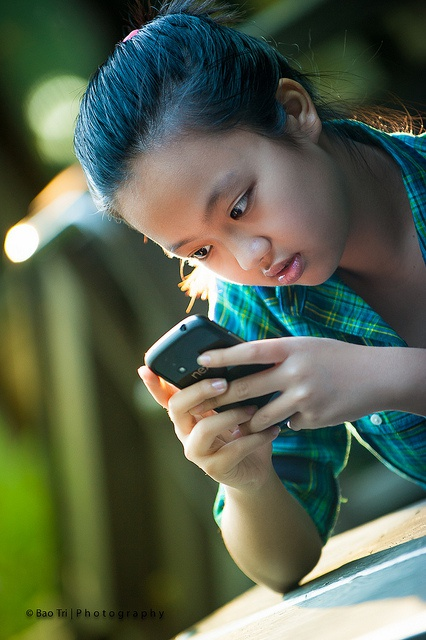Describe the objects in this image and their specific colors. I can see people in darkgreen, black, gray, darkgray, and teal tones and cell phone in darkgreen, black, darkblue, white, and teal tones in this image. 